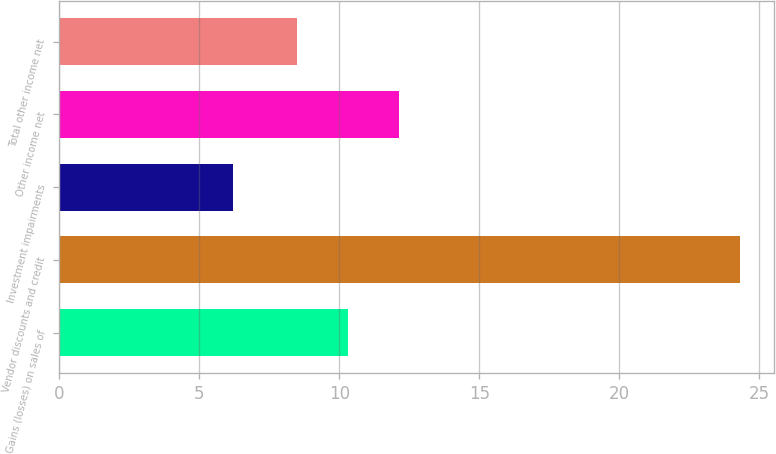Convert chart. <chart><loc_0><loc_0><loc_500><loc_500><bar_chart><fcel>Gains (losses) on sales of<fcel>Vendor discounts and credit<fcel>Investment impairments<fcel>Other income net<fcel>Total other income net<nl><fcel>10.31<fcel>24.3<fcel>6.2<fcel>12.12<fcel>8.5<nl></chart> 